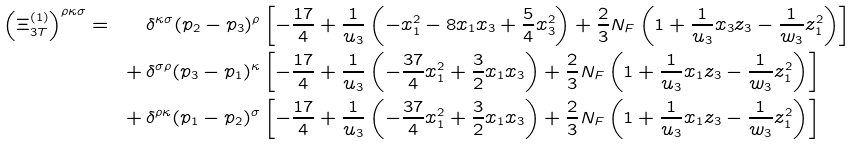<formula> <loc_0><loc_0><loc_500><loc_500>\left ( \Xi _ { 3 T } ^ { ( 1 ) } \right ) ^ { \rho \kappa \sigma } = \quad & \delta ^ { \kappa \sigma } ( p _ { 2 } - p _ { 3 } ) ^ { \rho } \left [ - \frac { 1 7 } { 4 } + \frac { 1 } { u _ { 3 } } \left ( - x _ { 1 } ^ { 2 } - 8 x _ { 1 } x _ { 3 } + \frac { 5 } { 4 } x _ { 3 } ^ { 2 } \right ) + \frac { 2 } { 3 } N _ { F } \left ( 1 + \frac { 1 } { u _ { 3 } } x _ { 3 } z _ { 3 } - \frac { 1 } { w _ { 3 } } z _ { 1 } ^ { 2 } \right ) \right ] \\ + \, & \delta ^ { \sigma \rho } ( p _ { 3 } - p _ { 1 } ) ^ { \kappa } \left [ - \frac { 1 7 } { 4 } + \frac { 1 } { u _ { 3 } } \left ( - \frac { 3 7 } { 4 } x _ { 1 } ^ { 2 } + \frac { 3 } { 2 } x _ { 1 } x _ { 3 } \right ) + \frac { 2 } { 3 } N _ { F } \left ( 1 + \frac { 1 } { u _ { 3 } } x _ { 1 } z _ { 3 } - \frac { 1 } { w _ { 3 } } z _ { 1 } ^ { 2 } \right ) \right ] \\ + \, & \delta ^ { \rho \kappa } ( p _ { 1 } - p _ { 2 } ) ^ { \sigma } \left [ - \frac { 1 7 } { 4 } + \frac { 1 } { u _ { 3 } } \left ( - \frac { 3 7 } { 4 } x _ { 1 } ^ { 2 } + \frac { 3 } { 2 } x _ { 1 } x _ { 3 } \right ) + \frac { 2 } { 3 } N _ { F } \left ( 1 + \frac { 1 } { u _ { 3 } } x _ { 1 } z _ { 3 } - \frac { 1 } { w _ { 3 } } z _ { 1 } ^ { 2 } \right ) \right ]</formula> 